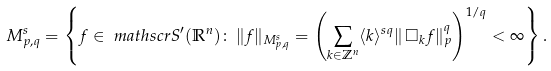<formula> <loc_0><loc_0><loc_500><loc_500>& M ^ { s } _ { p , q } = \left \{ f \in \ m a t h s c r { S } ^ { \prime } ( \mathbb { R } ^ { n } ) \colon \, \| f \| _ { M ^ { s } _ { p , q } } = \left ( \sum _ { k \in \mathbb { Z } ^ { n } } \langle k \rangle ^ { s q } \| \, \Box _ { k } f \| _ { p } ^ { q } \right ) ^ { 1 / q } < \infty \right \} .</formula> 